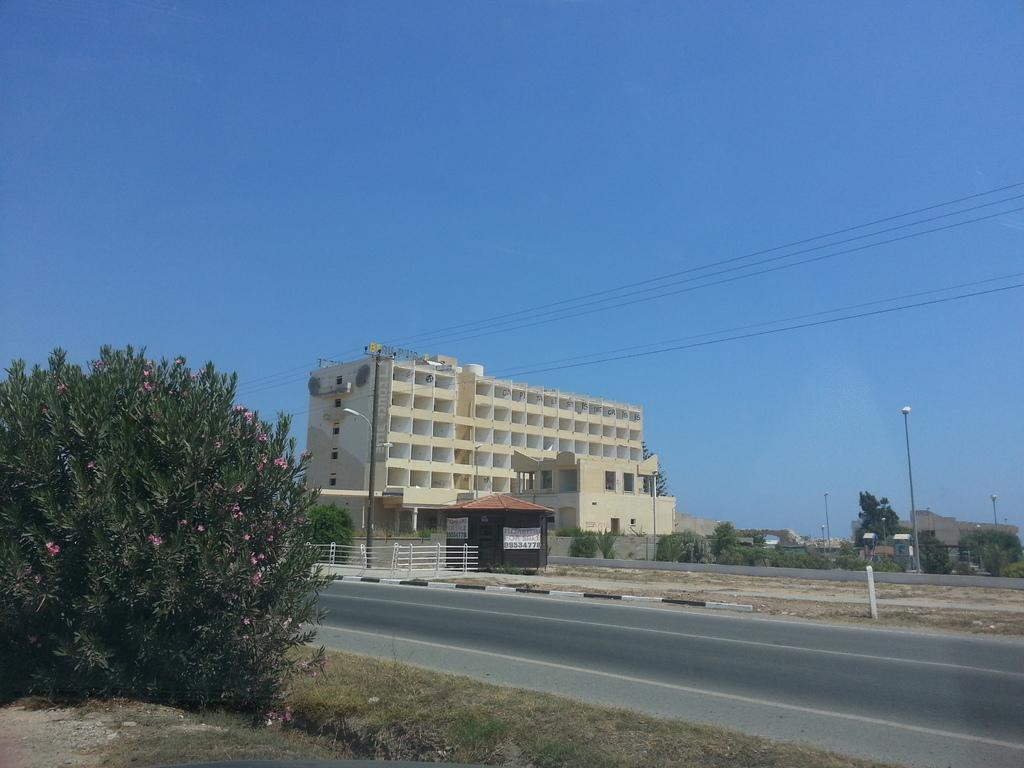What type of structure can be seen in the image? There is a building in the image. What are the vertical structures with signs or lights on them called? Street poles are present in the image. What type of vegetation is visible in the image? Plants and a group of trees are visible in the image. What type of ground surface is present in the image? Grass is present in the image. What type of pathway is visible in the image? There is a pathway in the image. What type of barrier is visible in the image? A fence is visible in the image. What type of decorative or informative signs are present in the image? Banners are present in the image. What type of vertical structures are visible in the image? Poles are visible in the image. What type of natural feature is visible in the image? A group of trees is visible in the image. What type of electrical infrastructure is present in the image? Wires are present in the image. What part of the natural environment is visible in the image? The sky is visible in the image. How does the bridge connect the two sides of the image? There is no bridge present in the image. Can you touch the sky in the image? The sky is not a physical object that can be touched; it is a part of the atmosphere visible in the image. 